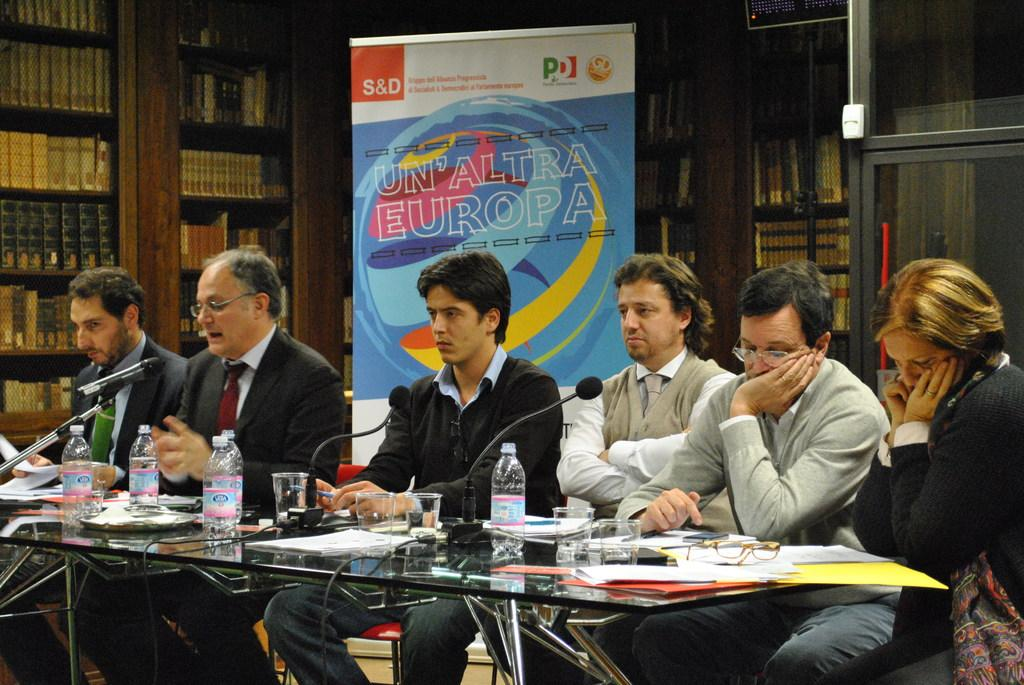<image>
Describe the image concisely. Several people at a desk in front of a sign reading Un'aAltra Europa 